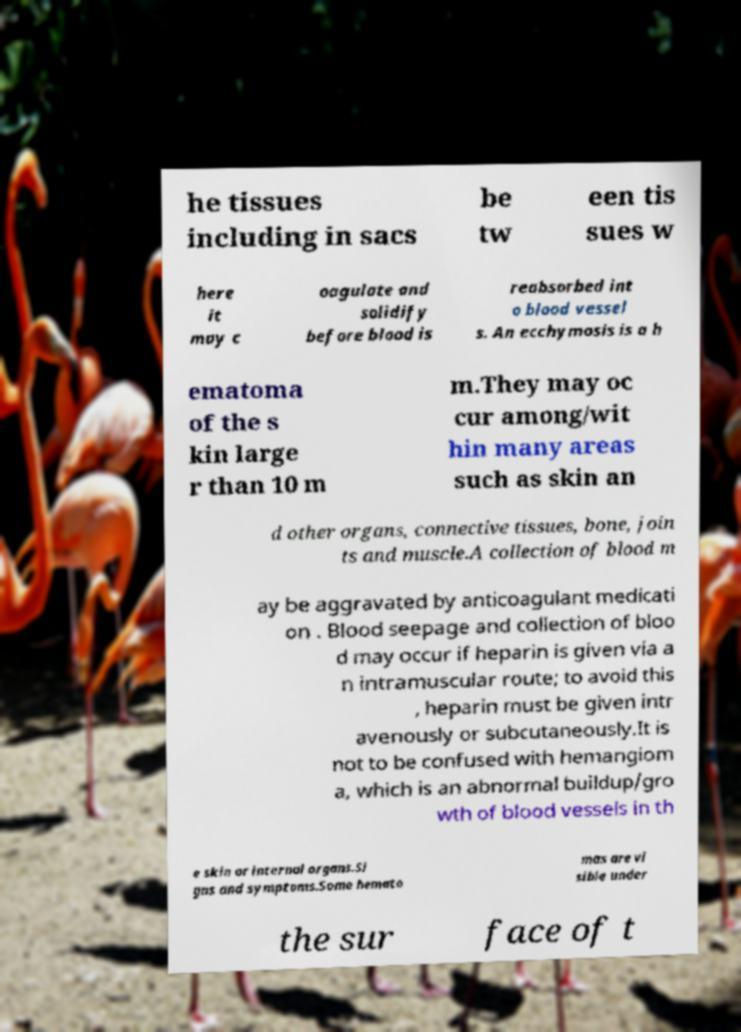Could you assist in decoding the text presented in this image and type it out clearly? he tissues including in sacs be tw een tis sues w here it may c oagulate and solidify before blood is reabsorbed int o blood vessel s. An ecchymosis is a h ematoma of the s kin large r than 10 m m.They may oc cur among/wit hin many areas such as skin an d other organs, connective tissues, bone, join ts and muscle.A collection of blood m ay be aggravated by anticoagulant medicati on . Blood seepage and collection of bloo d may occur if heparin is given via a n intramuscular route; to avoid this , heparin must be given intr avenously or subcutaneously.It is not to be confused with hemangiom a, which is an abnormal buildup/gro wth of blood vessels in th e skin or internal organs.Si gns and symptoms.Some hemato mas are vi sible under the sur face of t 